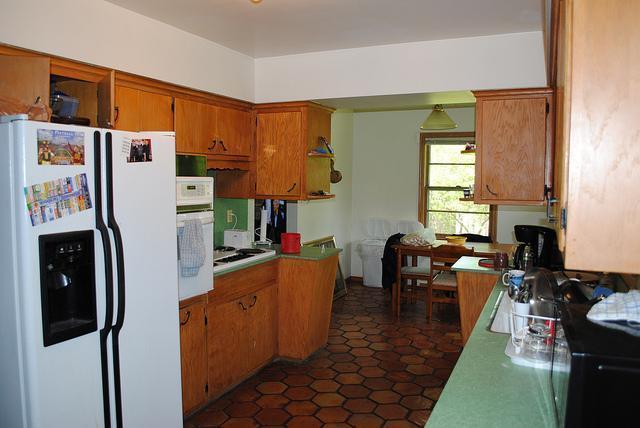How many doors are on the fridge?
Give a very brief answer. 2. How many refrigerators are in the picture?
Give a very brief answer. 1. How many train cars have some yellow on them?
Give a very brief answer. 0. 